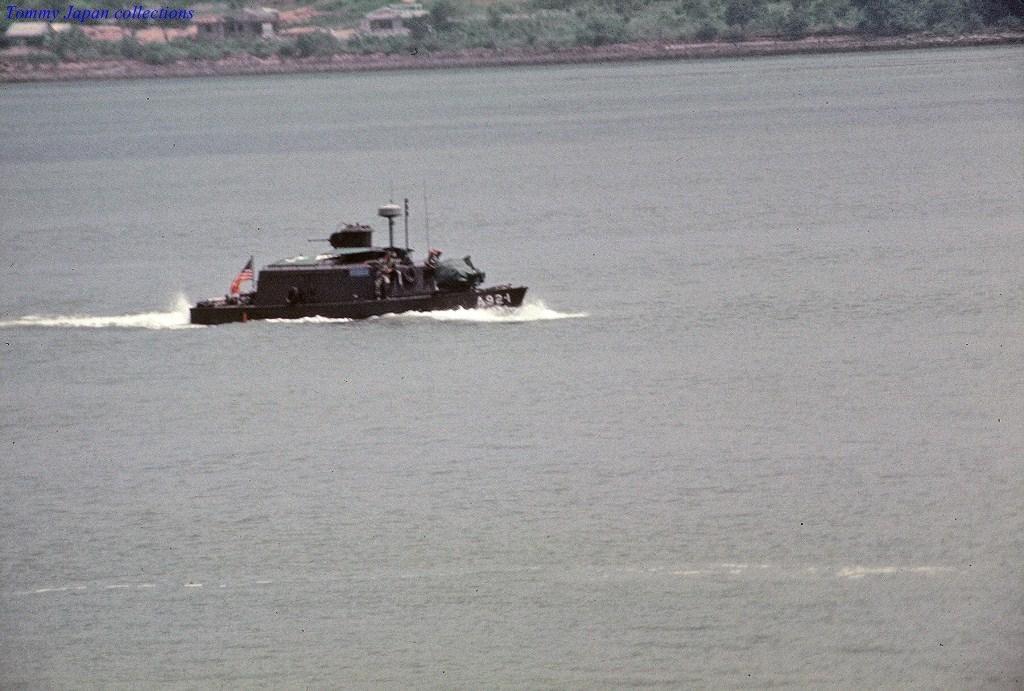How would you summarize this image in a sentence or two? In this image there is one lake and in the lake there is one ship, and in the background there are some trees buildings. At the top of the image there is some text. 